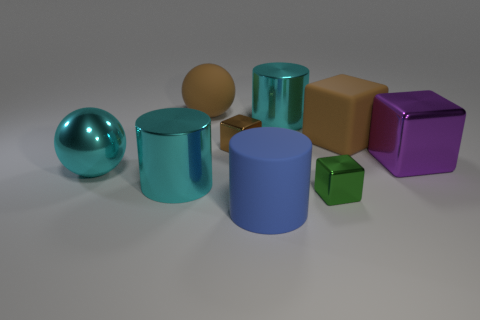Can you tell me how many objects there are, and how do they differ in color? There are seven objects in the image. Starting from the left, there is a teal sphere, a teal cylinder, a tan cube, another teal cylinder with a different hue, a brown cube, a violet cube, and a smaller green cube. 